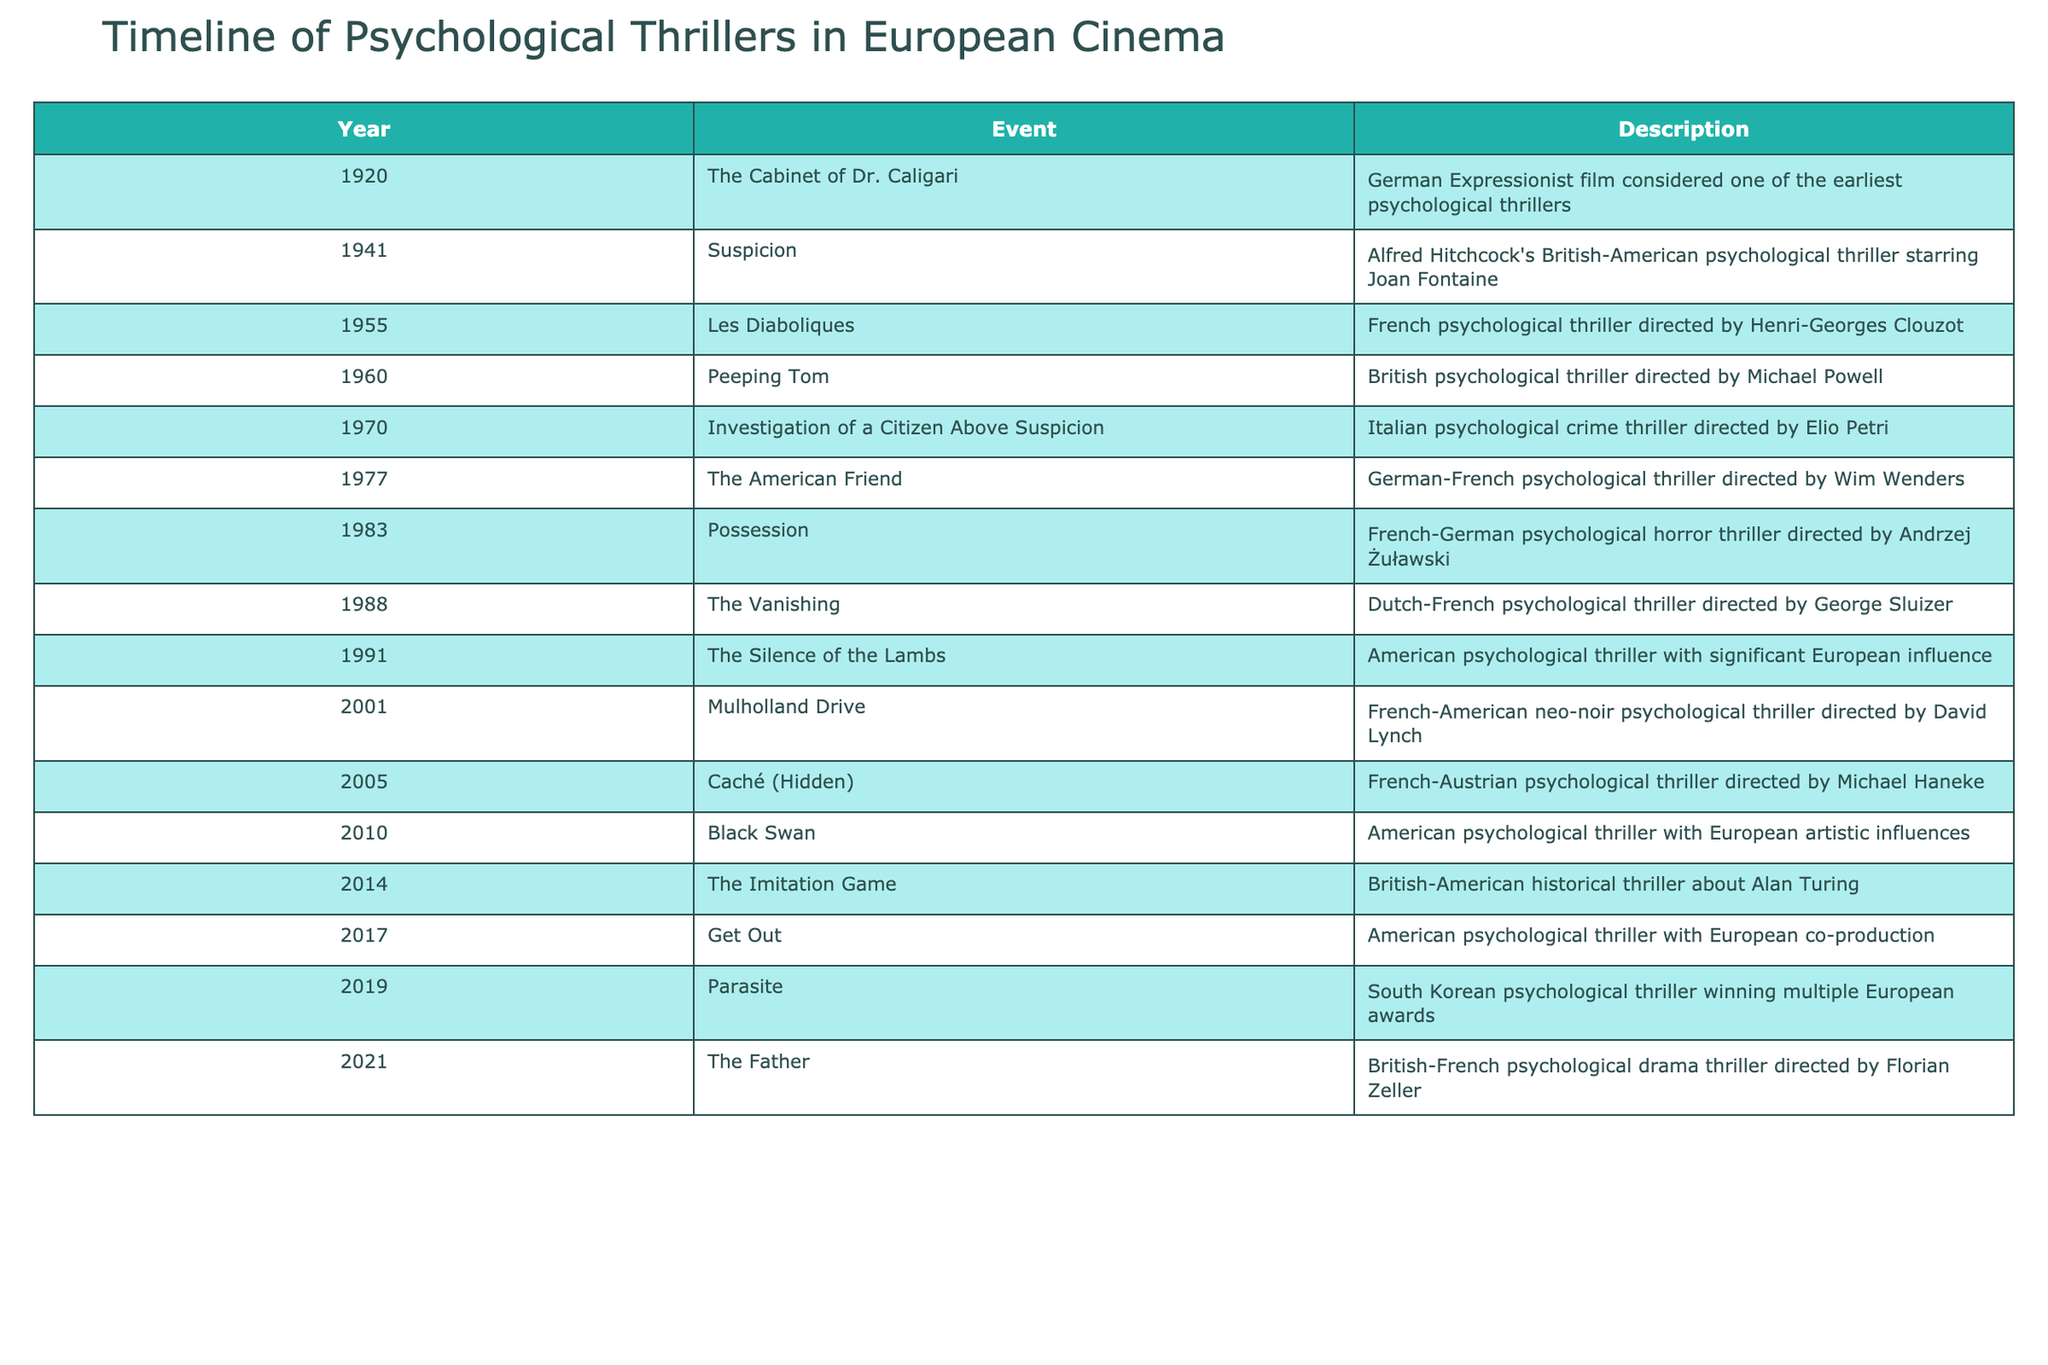What year was "The Cabinet of Dr. Caligari" released? The table lists "The Cabinet of Dr. Caligari" under the year 1920.
Answer: 1920 Which film directed by Henri-Georges Clouzot is noted in the table? The table mentions "Les Diaboliques," which is directed by Henri-Georges Clouzot in 1955.
Answer: Les Diaboliques How many psychological thrillers were released in the 1980s? According to the table, two psychological thrillers were released in the 1980s: "Possession" (1983) and "The Vanishing" (1988).
Answer: 2 Was "Parasite" a European psychological thriller? The table states that "Parasite," a South Korean psychological thriller, won multiple European awards, but does not classify it as a European film.
Answer: No What is the chronological order of the first three psychological thrillers listed? The first three psychological thrillers according to the table are "The Cabinet of Dr. Caligari" (1920), "Suspicion" (1941), and "Les Diaboliques" (1955), respectively.
Answer: 1920, 1941, 1955 Which film had a German-French collaboration and was directed by Wim Wenders? The film that fits this description according to the table is "The American Friend," released in 1977.
Answer: The American Friend How many years separate the release of "Mulholland Drive" and "Caché (Hidden)?" "Mulholland Drive" was released in 2001 and "Caché (Hidden)" in 2005, meaning they are separated by four years.
Answer: 4 years Are there any films in the table that have both American and European influences or co-productions listed? Yes, the table lists "The Silence of the Lambs" (1991) and "Get Out" (2017) as American psychological thrillers with significant European influences or co-productions.
Answer: Yes What genre is "The Father" categorized under as per the table? According to the table, "The Father" is categorized as a British-French psychological drama thriller, indicating it falls within both psychological and dramatic genres.
Answer: Psychological drama thriller 